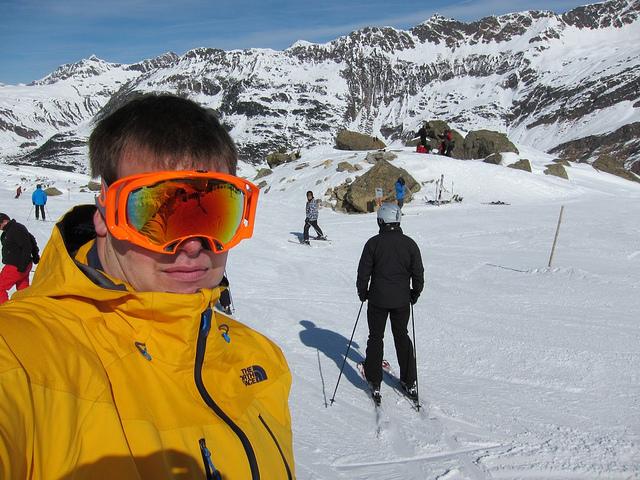What kind of goggles is the man in the foreground wearing?
Write a very short answer. Ski. Would a cactus thrive out here?
Give a very brief answer. No. What do you call this type of picture?
Be succinct. Selfie. 